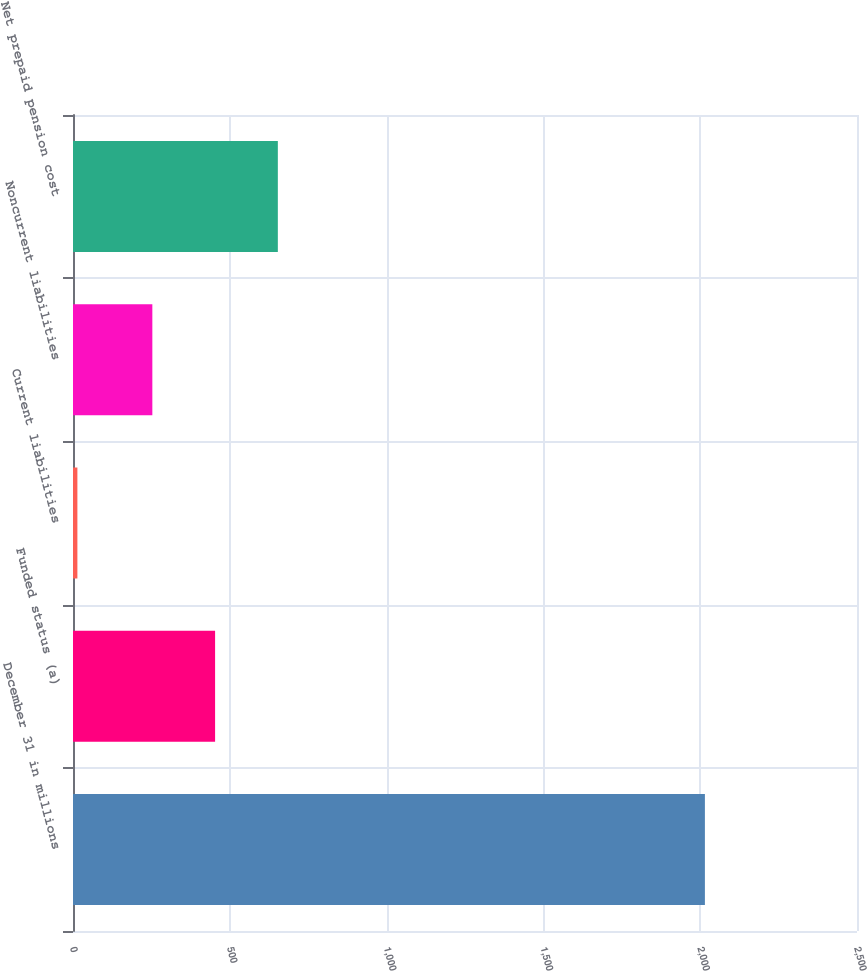Convert chart to OTSL. <chart><loc_0><loc_0><loc_500><loc_500><bar_chart><fcel>December 31 in millions<fcel>Funded status (a)<fcel>Current liabilities<fcel>Noncurrent liabilities<fcel>Net prepaid pension cost<nl><fcel>2015<fcel>453.1<fcel>14<fcel>253<fcel>653.2<nl></chart> 